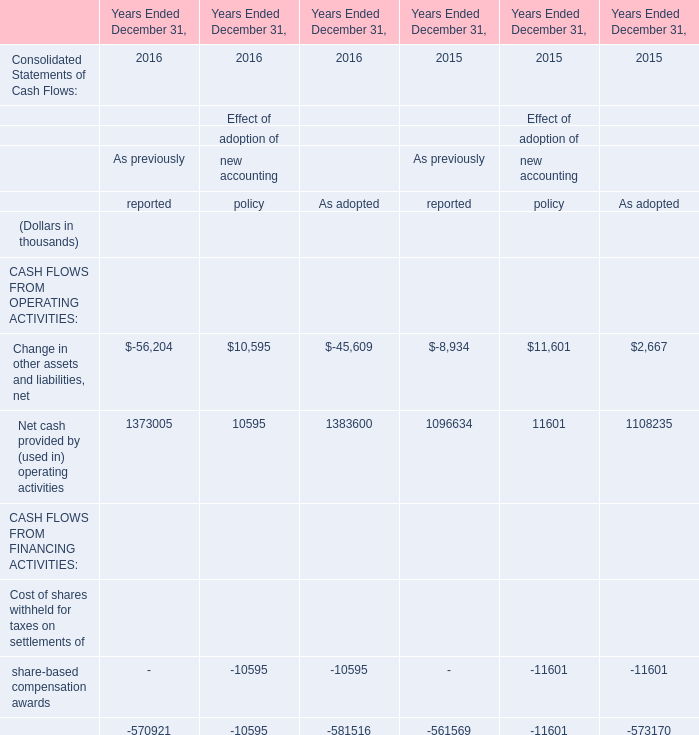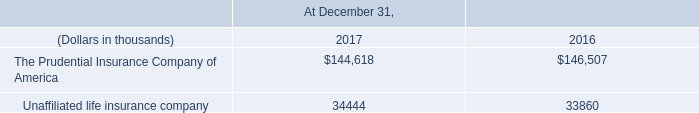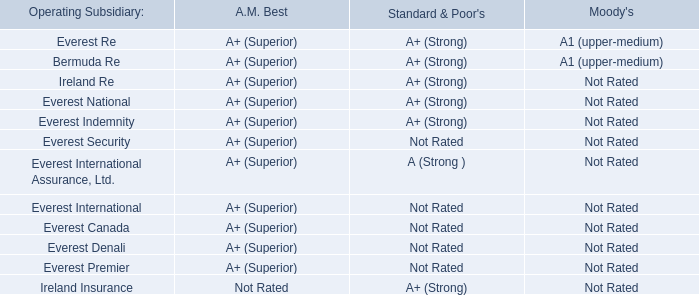In the year with the most Net cash provided by (used in) operating activities, what is the growth rate of Change in other assets and liabilities, net? (in %) 
Computations: ((8934 - 56204) / 56204)
Answer: -0.84104. 